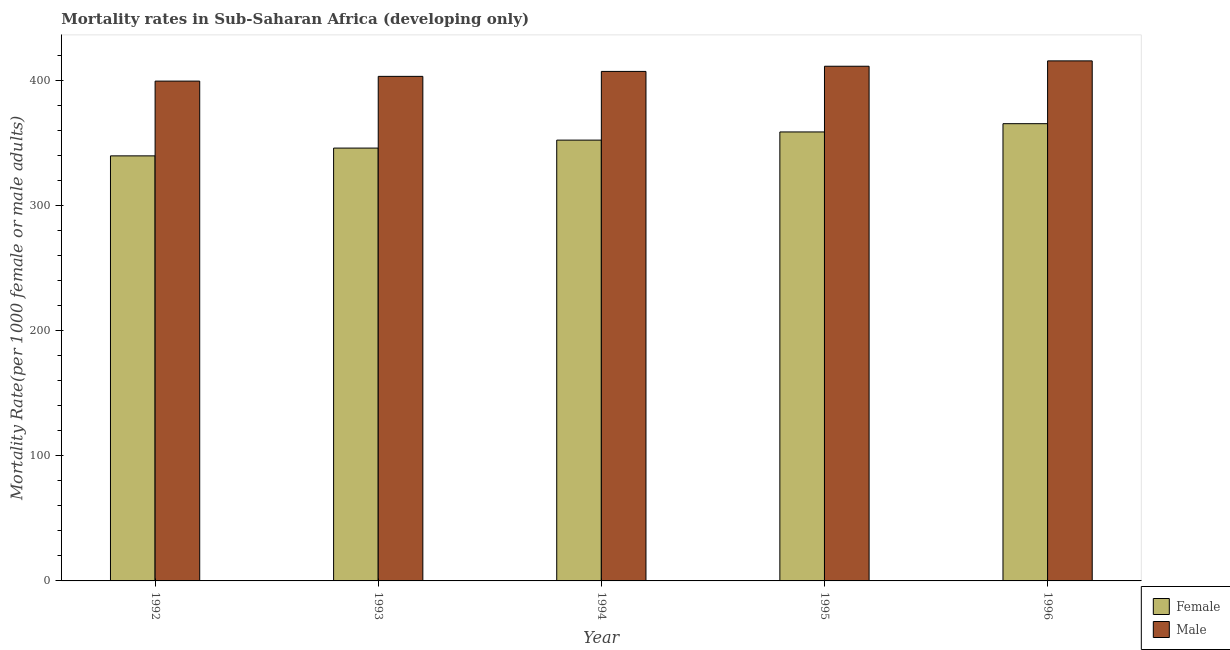How many groups of bars are there?
Keep it short and to the point. 5. Are the number of bars per tick equal to the number of legend labels?
Give a very brief answer. Yes. Are the number of bars on each tick of the X-axis equal?
Provide a succinct answer. Yes. How many bars are there on the 4th tick from the left?
Make the answer very short. 2. What is the label of the 2nd group of bars from the left?
Your answer should be very brief. 1993. What is the female mortality rate in 1996?
Your answer should be very brief. 365.42. Across all years, what is the maximum male mortality rate?
Your answer should be compact. 415.61. Across all years, what is the minimum female mortality rate?
Provide a succinct answer. 339.7. In which year was the male mortality rate maximum?
Offer a terse response. 1996. What is the total male mortality rate in the graph?
Offer a very short reply. 2036.81. What is the difference between the male mortality rate in 1994 and that in 1995?
Give a very brief answer. -4.14. What is the difference between the male mortality rate in 1992 and the female mortality rate in 1995?
Keep it short and to the point. -11.87. What is the average female mortality rate per year?
Your answer should be compact. 352.43. In how many years, is the female mortality rate greater than 120?
Provide a short and direct response. 5. What is the ratio of the male mortality rate in 1995 to that in 1996?
Provide a short and direct response. 0.99. Is the difference between the female mortality rate in 1992 and 1994 greater than the difference between the male mortality rate in 1992 and 1994?
Your answer should be very brief. No. What is the difference between the highest and the second highest female mortality rate?
Offer a very short reply. 6.61. What is the difference between the highest and the lowest female mortality rate?
Your answer should be compact. 25.72. In how many years, is the male mortality rate greater than the average male mortality rate taken over all years?
Keep it short and to the point. 2. Is the sum of the male mortality rate in 1992 and 1995 greater than the maximum female mortality rate across all years?
Provide a succinct answer. Yes. What does the 1st bar from the right in 1995 represents?
Give a very brief answer. Male. How many bars are there?
Keep it short and to the point. 10. Does the graph contain grids?
Your response must be concise. No. Where does the legend appear in the graph?
Provide a short and direct response. Bottom right. How many legend labels are there?
Provide a short and direct response. 2. What is the title of the graph?
Provide a succinct answer. Mortality rates in Sub-Saharan Africa (developing only). Does "Food" appear as one of the legend labels in the graph?
Your response must be concise. No. What is the label or title of the Y-axis?
Offer a terse response. Mortality Rate(per 1000 female or male adults). What is the Mortality Rate(per 1000 female or male adults) of Female in 1992?
Your response must be concise. 339.7. What is the Mortality Rate(per 1000 female or male adults) of Male in 1992?
Give a very brief answer. 399.45. What is the Mortality Rate(per 1000 female or male adults) of Female in 1993?
Make the answer very short. 345.91. What is the Mortality Rate(per 1000 female or male adults) in Male in 1993?
Make the answer very short. 403.23. What is the Mortality Rate(per 1000 female or male adults) in Female in 1994?
Provide a succinct answer. 352.28. What is the Mortality Rate(per 1000 female or male adults) in Male in 1994?
Ensure brevity in your answer.  407.19. What is the Mortality Rate(per 1000 female or male adults) in Female in 1995?
Your answer should be very brief. 358.81. What is the Mortality Rate(per 1000 female or male adults) of Male in 1995?
Your answer should be compact. 411.33. What is the Mortality Rate(per 1000 female or male adults) in Female in 1996?
Offer a terse response. 365.42. What is the Mortality Rate(per 1000 female or male adults) in Male in 1996?
Your response must be concise. 415.61. Across all years, what is the maximum Mortality Rate(per 1000 female or male adults) of Female?
Keep it short and to the point. 365.42. Across all years, what is the maximum Mortality Rate(per 1000 female or male adults) of Male?
Give a very brief answer. 415.61. Across all years, what is the minimum Mortality Rate(per 1000 female or male adults) in Female?
Your answer should be compact. 339.7. Across all years, what is the minimum Mortality Rate(per 1000 female or male adults) in Male?
Your response must be concise. 399.45. What is the total Mortality Rate(per 1000 female or male adults) in Female in the graph?
Offer a very short reply. 1762.13. What is the total Mortality Rate(per 1000 female or male adults) of Male in the graph?
Keep it short and to the point. 2036.81. What is the difference between the Mortality Rate(per 1000 female or male adults) of Female in 1992 and that in 1993?
Give a very brief answer. -6.21. What is the difference between the Mortality Rate(per 1000 female or male adults) in Male in 1992 and that in 1993?
Make the answer very short. -3.78. What is the difference between the Mortality Rate(per 1000 female or male adults) in Female in 1992 and that in 1994?
Your answer should be very brief. -12.59. What is the difference between the Mortality Rate(per 1000 female or male adults) in Male in 1992 and that in 1994?
Your response must be concise. -7.73. What is the difference between the Mortality Rate(per 1000 female or male adults) of Female in 1992 and that in 1995?
Your answer should be very brief. -19.11. What is the difference between the Mortality Rate(per 1000 female or male adults) in Male in 1992 and that in 1995?
Offer a very short reply. -11.87. What is the difference between the Mortality Rate(per 1000 female or male adults) of Female in 1992 and that in 1996?
Your answer should be very brief. -25.72. What is the difference between the Mortality Rate(per 1000 female or male adults) of Male in 1992 and that in 1996?
Your answer should be compact. -16.16. What is the difference between the Mortality Rate(per 1000 female or male adults) in Female in 1993 and that in 1994?
Give a very brief answer. -6.38. What is the difference between the Mortality Rate(per 1000 female or male adults) of Male in 1993 and that in 1994?
Your answer should be compact. -3.95. What is the difference between the Mortality Rate(per 1000 female or male adults) in Female in 1993 and that in 1995?
Your response must be concise. -12.91. What is the difference between the Mortality Rate(per 1000 female or male adults) of Male in 1993 and that in 1995?
Your answer should be very brief. -8.09. What is the difference between the Mortality Rate(per 1000 female or male adults) in Female in 1993 and that in 1996?
Your response must be concise. -19.52. What is the difference between the Mortality Rate(per 1000 female or male adults) in Male in 1993 and that in 1996?
Give a very brief answer. -12.37. What is the difference between the Mortality Rate(per 1000 female or male adults) of Female in 1994 and that in 1995?
Offer a very short reply. -6.53. What is the difference between the Mortality Rate(per 1000 female or male adults) of Male in 1994 and that in 1995?
Offer a terse response. -4.14. What is the difference between the Mortality Rate(per 1000 female or male adults) of Female in 1994 and that in 1996?
Ensure brevity in your answer.  -13.14. What is the difference between the Mortality Rate(per 1000 female or male adults) of Male in 1994 and that in 1996?
Your answer should be compact. -8.42. What is the difference between the Mortality Rate(per 1000 female or male adults) of Female in 1995 and that in 1996?
Provide a short and direct response. -6.61. What is the difference between the Mortality Rate(per 1000 female or male adults) of Male in 1995 and that in 1996?
Offer a terse response. -4.28. What is the difference between the Mortality Rate(per 1000 female or male adults) in Female in 1992 and the Mortality Rate(per 1000 female or male adults) in Male in 1993?
Your response must be concise. -63.53. What is the difference between the Mortality Rate(per 1000 female or male adults) of Female in 1992 and the Mortality Rate(per 1000 female or male adults) of Male in 1994?
Keep it short and to the point. -67.49. What is the difference between the Mortality Rate(per 1000 female or male adults) of Female in 1992 and the Mortality Rate(per 1000 female or male adults) of Male in 1995?
Make the answer very short. -71.63. What is the difference between the Mortality Rate(per 1000 female or male adults) of Female in 1992 and the Mortality Rate(per 1000 female or male adults) of Male in 1996?
Your answer should be compact. -75.91. What is the difference between the Mortality Rate(per 1000 female or male adults) in Female in 1993 and the Mortality Rate(per 1000 female or male adults) in Male in 1994?
Your response must be concise. -61.28. What is the difference between the Mortality Rate(per 1000 female or male adults) of Female in 1993 and the Mortality Rate(per 1000 female or male adults) of Male in 1995?
Make the answer very short. -65.42. What is the difference between the Mortality Rate(per 1000 female or male adults) of Female in 1993 and the Mortality Rate(per 1000 female or male adults) of Male in 1996?
Offer a terse response. -69.7. What is the difference between the Mortality Rate(per 1000 female or male adults) in Female in 1994 and the Mortality Rate(per 1000 female or male adults) in Male in 1995?
Your response must be concise. -59.04. What is the difference between the Mortality Rate(per 1000 female or male adults) of Female in 1994 and the Mortality Rate(per 1000 female or male adults) of Male in 1996?
Your answer should be very brief. -63.32. What is the difference between the Mortality Rate(per 1000 female or male adults) of Female in 1995 and the Mortality Rate(per 1000 female or male adults) of Male in 1996?
Provide a short and direct response. -56.79. What is the average Mortality Rate(per 1000 female or male adults) in Female per year?
Provide a short and direct response. 352.43. What is the average Mortality Rate(per 1000 female or male adults) in Male per year?
Your answer should be very brief. 407.36. In the year 1992, what is the difference between the Mortality Rate(per 1000 female or male adults) in Female and Mortality Rate(per 1000 female or male adults) in Male?
Your answer should be compact. -59.75. In the year 1993, what is the difference between the Mortality Rate(per 1000 female or male adults) of Female and Mortality Rate(per 1000 female or male adults) of Male?
Your answer should be very brief. -57.33. In the year 1994, what is the difference between the Mortality Rate(per 1000 female or male adults) of Female and Mortality Rate(per 1000 female or male adults) of Male?
Keep it short and to the point. -54.9. In the year 1995, what is the difference between the Mortality Rate(per 1000 female or male adults) of Female and Mortality Rate(per 1000 female or male adults) of Male?
Ensure brevity in your answer.  -52.51. In the year 1996, what is the difference between the Mortality Rate(per 1000 female or male adults) in Female and Mortality Rate(per 1000 female or male adults) in Male?
Your answer should be very brief. -50.18. What is the ratio of the Mortality Rate(per 1000 female or male adults) of Female in 1992 to that in 1993?
Your response must be concise. 0.98. What is the ratio of the Mortality Rate(per 1000 female or male adults) in Male in 1992 to that in 1993?
Ensure brevity in your answer.  0.99. What is the ratio of the Mortality Rate(per 1000 female or male adults) of Female in 1992 to that in 1995?
Offer a terse response. 0.95. What is the ratio of the Mortality Rate(per 1000 female or male adults) in Male in 1992 to that in 1995?
Your response must be concise. 0.97. What is the ratio of the Mortality Rate(per 1000 female or male adults) of Female in 1992 to that in 1996?
Keep it short and to the point. 0.93. What is the ratio of the Mortality Rate(per 1000 female or male adults) in Male in 1992 to that in 1996?
Provide a succinct answer. 0.96. What is the ratio of the Mortality Rate(per 1000 female or male adults) of Female in 1993 to that in 1994?
Your answer should be very brief. 0.98. What is the ratio of the Mortality Rate(per 1000 female or male adults) of Male in 1993 to that in 1994?
Keep it short and to the point. 0.99. What is the ratio of the Mortality Rate(per 1000 female or male adults) of Female in 1993 to that in 1995?
Give a very brief answer. 0.96. What is the ratio of the Mortality Rate(per 1000 female or male adults) in Male in 1993 to that in 1995?
Make the answer very short. 0.98. What is the ratio of the Mortality Rate(per 1000 female or male adults) of Female in 1993 to that in 1996?
Offer a terse response. 0.95. What is the ratio of the Mortality Rate(per 1000 female or male adults) of Male in 1993 to that in 1996?
Provide a succinct answer. 0.97. What is the ratio of the Mortality Rate(per 1000 female or male adults) of Female in 1994 to that in 1995?
Keep it short and to the point. 0.98. What is the ratio of the Mortality Rate(per 1000 female or male adults) in Male in 1994 to that in 1995?
Make the answer very short. 0.99. What is the ratio of the Mortality Rate(per 1000 female or male adults) in Female in 1994 to that in 1996?
Keep it short and to the point. 0.96. What is the ratio of the Mortality Rate(per 1000 female or male adults) in Male in 1994 to that in 1996?
Keep it short and to the point. 0.98. What is the ratio of the Mortality Rate(per 1000 female or male adults) of Female in 1995 to that in 1996?
Your answer should be compact. 0.98. What is the difference between the highest and the second highest Mortality Rate(per 1000 female or male adults) in Female?
Offer a terse response. 6.61. What is the difference between the highest and the second highest Mortality Rate(per 1000 female or male adults) in Male?
Ensure brevity in your answer.  4.28. What is the difference between the highest and the lowest Mortality Rate(per 1000 female or male adults) of Female?
Keep it short and to the point. 25.72. What is the difference between the highest and the lowest Mortality Rate(per 1000 female or male adults) of Male?
Offer a very short reply. 16.16. 